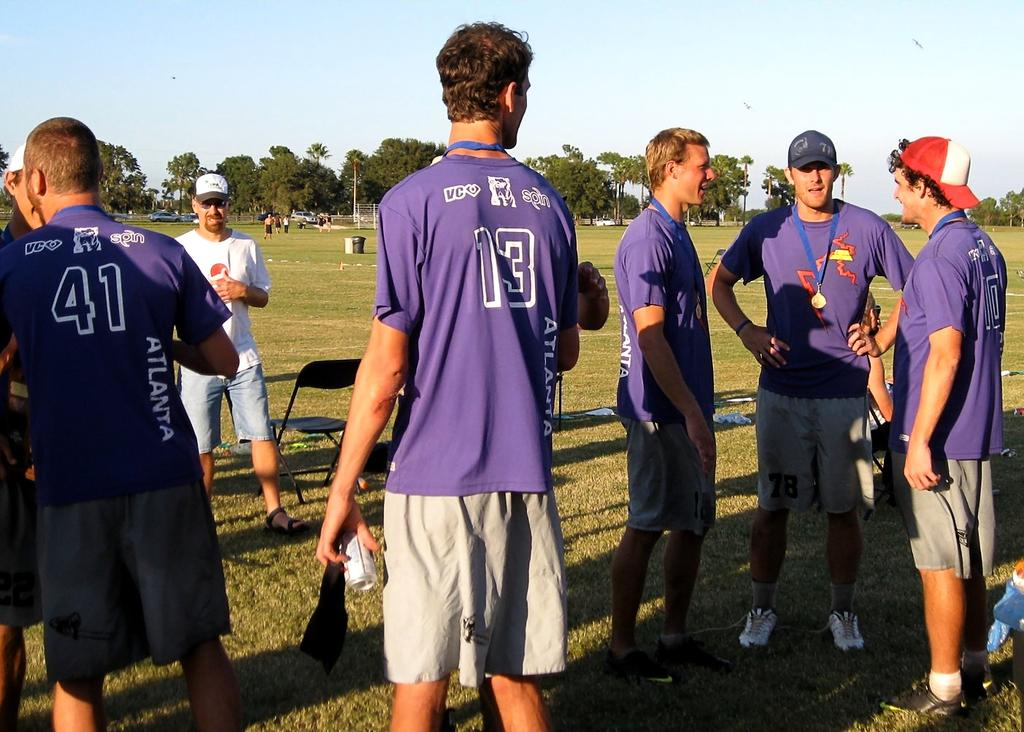<image>
Relay a brief, clear account of the picture shown. Number 13 is standing by himself while his teammates talk to each other. 